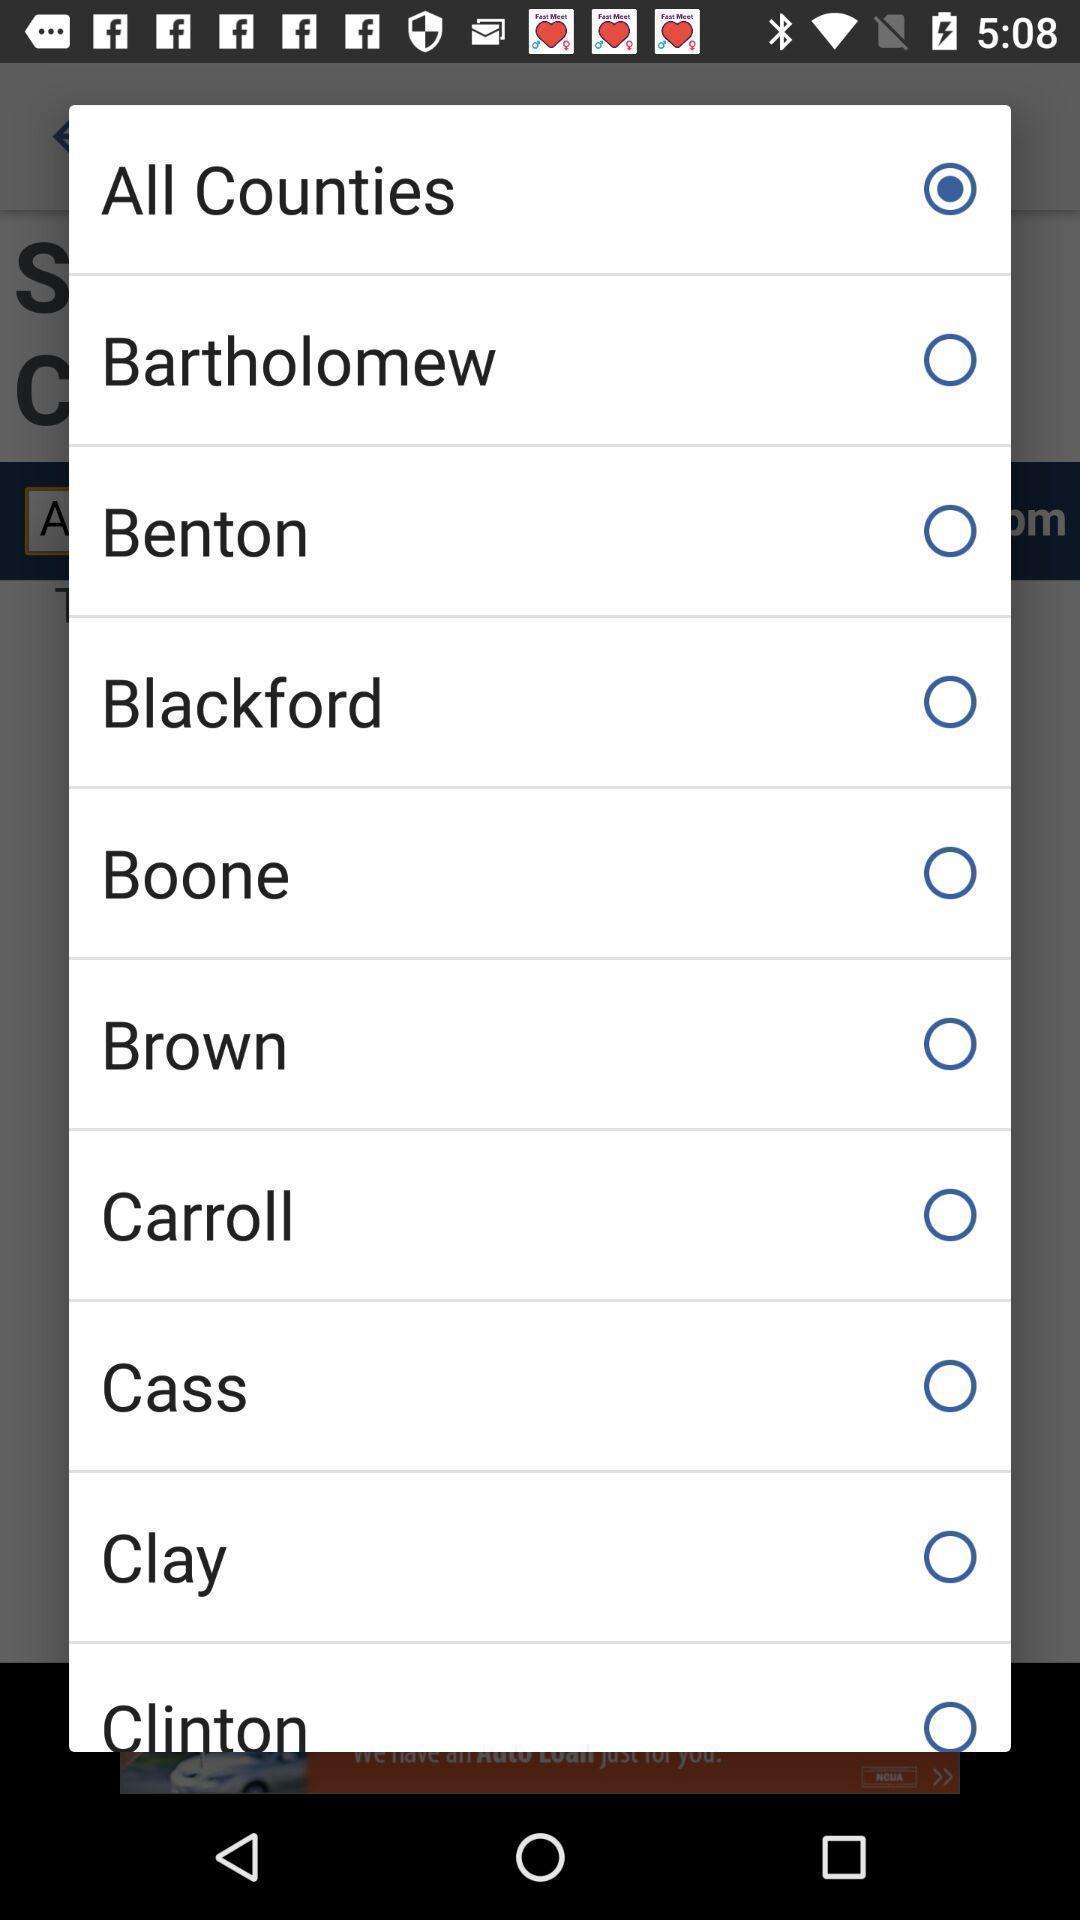Give me a narrative description of this picture. Pop-up shows to select different options. 